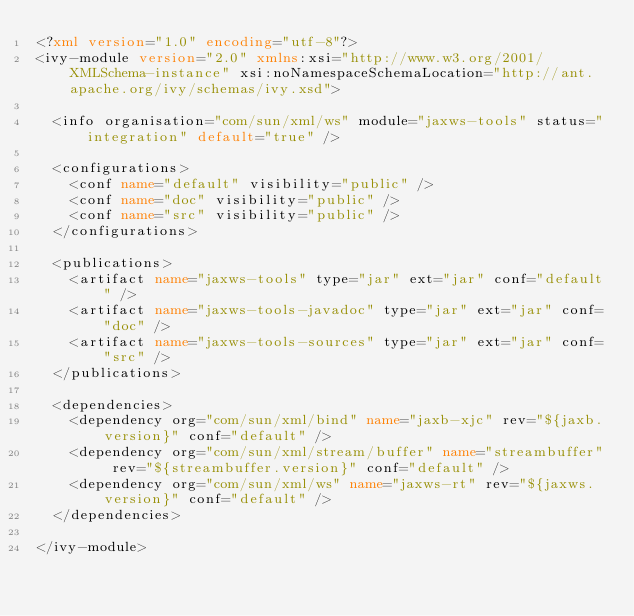Convert code to text. <code><loc_0><loc_0><loc_500><loc_500><_XML_><?xml version="1.0" encoding="utf-8"?>
<ivy-module version="2.0" xmlns:xsi="http://www.w3.org/2001/XMLSchema-instance" xsi:noNamespaceSchemaLocation="http://ant.apache.org/ivy/schemas/ivy.xsd">

	<info organisation="com/sun/xml/ws" module="jaxws-tools" status="integration" default="true" />

	<configurations>
		<conf name="default" visibility="public" />
		<conf name="doc" visibility="public" />
		<conf name="src" visibility="public" />
	</configurations>

	<publications>
		<artifact name="jaxws-tools" type="jar" ext="jar" conf="default" />
		<artifact name="jaxws-tools-javadoc" type="jar" ext="jar" conf="doc" />
		<artifact name="jaxws-tools-sources" type="jar" ext="jar" conf="src" />
	</publications>

	<dependencies>
		<dependency org="com/sun/xml/bind" name="jaxb-xjc" rev="${jaxb.version}" conf="default" />
		<dependency org="com/sun/xml/stream/buffer" name="streambuffer" rev="${streambuffer.version}" conf="default" />
		<dependency org="com/sun/xml/ws" name="jaxws-rt" rev="${jaxws.version}" conf="default" />
	</dependencies>

</ivy-module></code> 